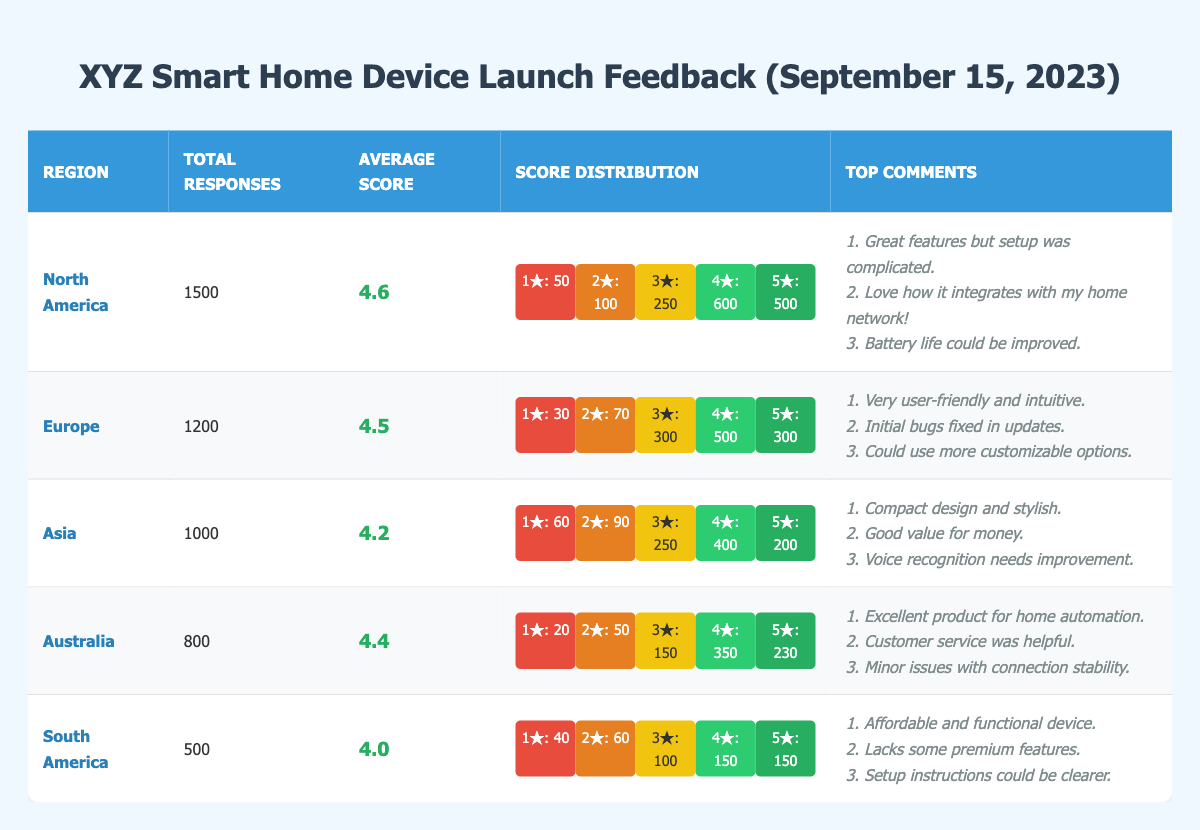What is the average score for customer feedback in North America? The average score for North America is explicitly stated in the table under the "Average Score" column, which shows a value of 4.6.
Answer: 4.6 How many total responses were received from customers in Europe? The total number of responses for Europe is stated in the "Total Responses" column, which shows a value of 1200.
Answer: 1200 Which region had the highest number of 5-star ratings? Looking into the "Score Distribution" for each region, North America has the highest count of 5-star ratings with a total of 500, compared to other regions.
Answer: North America What is the difference between the total responses in North America and South America? North America received 1500 responses and South America received 500. The difference is calculated as 1500 - 500 = 1000.
Answer: 1000 In which region were there fewer than 100 total responses rated with 1 star? From the "Score Distribution," check the 1 star ratings: North America (50), Europe (30), Asia (60), Australia (20), and South America (40). All these regions have fewer than 100 responses rated with 1 star.
Answer: All regions What is the average score across all regions? First, sum the average scores from each region: 4.6 (North America) + 4.5 (Europe) + 4.2 (Asia) + 4.4 (Australia) + 4.0 (South America) = 22.0. Next, divide by the number of regions (5). Therefore, the average score is 22.0 / 5 = 4.4.
Answer: 4.4 Is the average customer feedback score in Asia higher than that in Australia? The average score for Asia is 4.2, and for Australia, it is 4.4. Since 4.2 < 4.4, the statement is false.
Answer: No Which region has the most diverse score distribution based on the number of different star ratings given? By examining the score distribution, each region has all five star categories. However, to determine diversity, consider the total counts across those categories. North America has significant numbers across scores (50, 100, 250, 600, 500), which indicates diversity.
Answer: North America What percentage of the total responses in South America were rated as 3 stars? In South America, there were 100 responses rated as 3 stars out of 500 total responses. To find the percentage, calculate (100/500) * 100 = 20%.
Answer: 20% Which region has the lowest average score and what is the score? By comparing the average scores for each region, South America has the lowest average score at 4.0.
Answer: South America, 4.0 What are the primary concerns mentioned by customers in Asia? The top comments for Asia include three concerns: "Compact design and stylish," "Good value for money," and "Voice recognition needs improvement."
Answer: Voice recognition needs improvement 